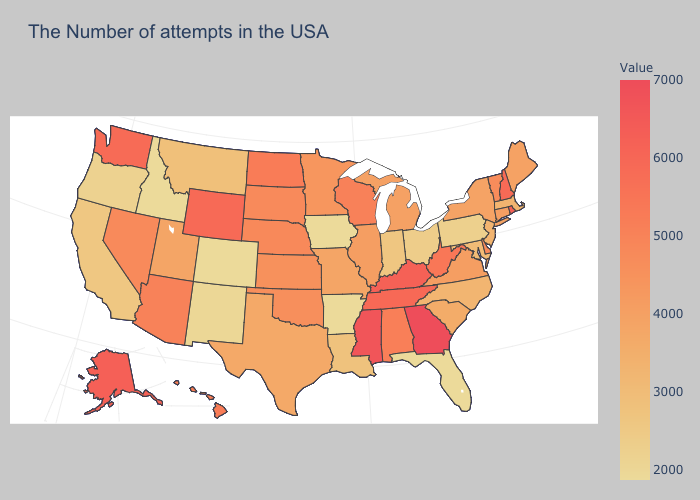Does the map have missing data?
Be succinct. No. Is the legend a continuous bar?
Give a very brief answer. Yes. Which states have the lowest value in the USA?
Write a very short answer. Florida, Arkansas, Iowa, Colorado, Idaho. Does Massachusetts have the lowest value in the USA?
Concise answer only. No. Among the states that border Tennessee , does Arkansas have the lowest value?
Quick response, please. Yes. 